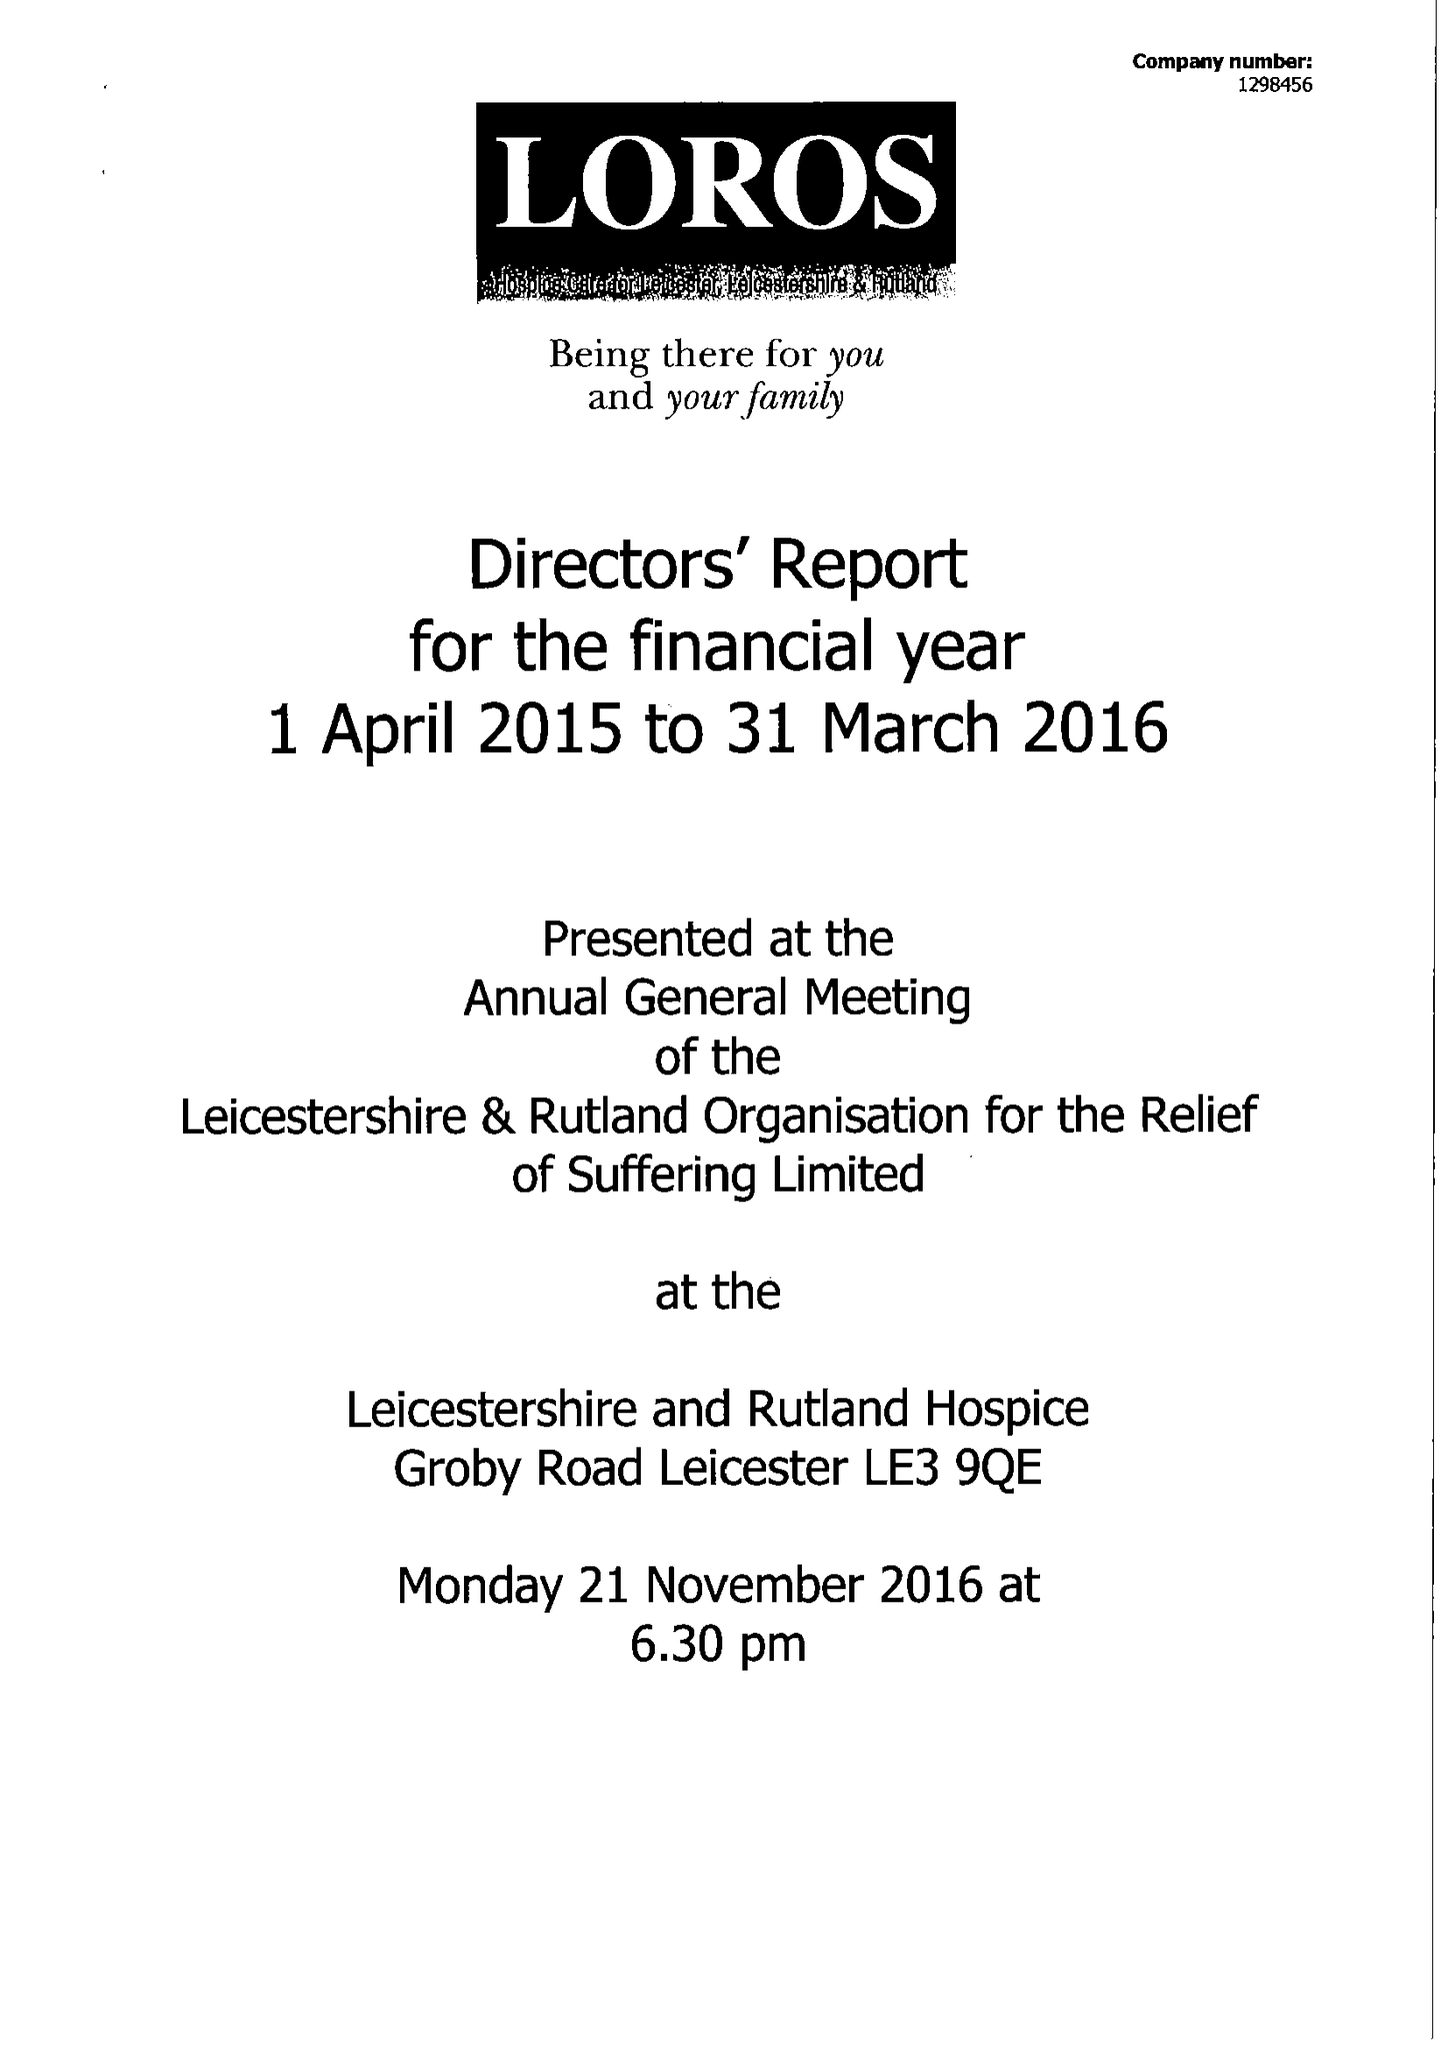What is the value for the address__street_line?
Answer the question using a single word or phrase. GROBY ROAD 